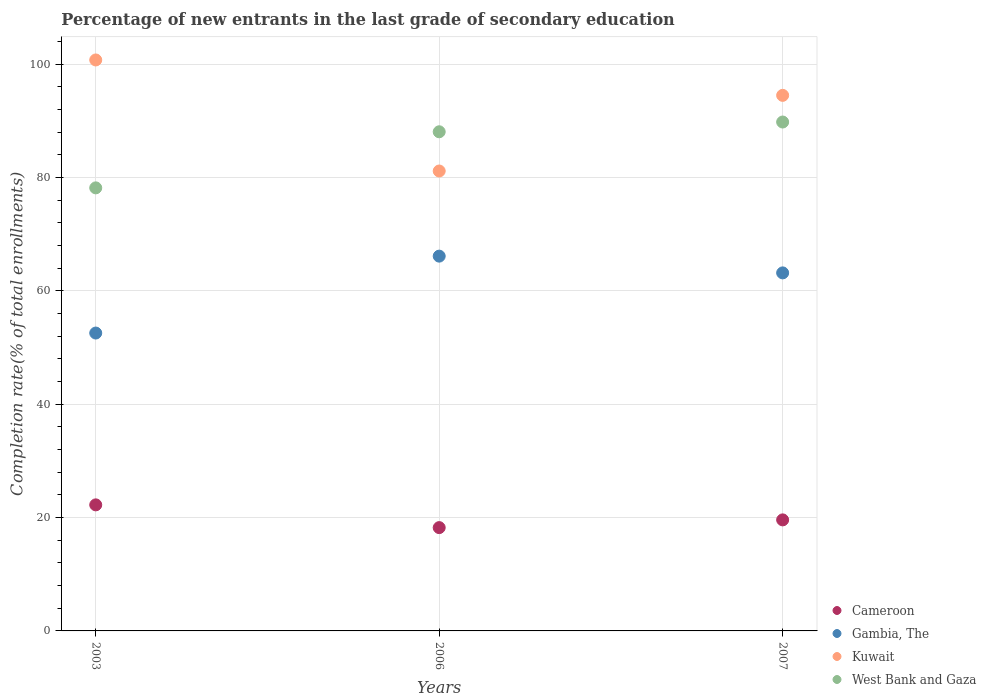Is the number of dotlines equal to the number of legend labels?
Ensure brevity in your answer.  Yes. What is the percentage of new entrants in Kuwait in 2003?
Your answer should be very brief. 100.72. Across all years, what is the maximum percentage of new entrants in Cameroon?
Provide a succinct answer. 22.24. Across all years, what is the minimum percentage of new entrants in Kuwait?
Provide a short and direct response. 81.13. In which year was the percentage of new entrants in Cameroon minimum?
Offer a terse response. 2006. What is the total percentage of new entrants in Cameroon in the graph?
Provide a short and direct response. 60.05. What is the difference between the percentage of new entrants in West Bank and Gaza in 2003 and that in 2006?
Make the answer very short. -9.89. What is the difference between the percentage of new entrants in West Bank and Gaza in 2006 and the percentage of new entrants in Cameroon in 2007?
Make the answer very short. 68.46. What is the average percentage of new entrants in Cameroon per year?
Provide a succinct answer. 20.02. In the year 2006, what is the difference between the percentage of new entrants in Kuwait and percentage of new entrants in Cameroon?
Your answer should be very brief. 62.91. What is the ratio of the percentage of new entrants in Kuwait in 2006 to that in 2007?
Your answer should be very brief. 0.86. Is the difference between the percentage of new entrants in Kuwait in 2003 and 2006 greater than the difference between the percentage of new entrants in Cameroon in 2003 and 2006?
Make the answer very short. Yes. What is the difference between the highest and the second highest percentage of new entrants in Kuwait?
Your answer should be very brief. 6.25. What is the difference between the highest and the lowest percentage of new entrants in Cameroon?
Provide a succinct answer. 4.01. Is the sum of the percentage of new entrants in Gambia, The in 2003 and 2006 greater than the maximum percentage of new entrants in Kuwait across all years?
Give a very brief answer. Yes. Is the percentage of new entrants in West Bank and Gaza strictly greater than the percentage of new entrants in Kuwait over the years?
Give a very brief answer. No. Is the percentage of new entrants in Kuwait strictly less than the percentage of new entrants in Gambia, The over the years?
Your answer should be compact. No. How many dotlines are there?
Make the answer very short. 4. How many years are there in the graph?
Give a very brief answer. 3. Are the values on the major ticks of Y-axis written in scientific E-notation?
Your answer should be very brief. No. Does the graph contain any zero values?
Make the answer very short. No. Does the graph contain grids?
Your answer should be compact. Yes. How many legend labels are there?
Provide a succinct answer. 4. How are the legend labels stacked?
Your response must be concise. Vertical. What is the title of the graph?
Your response must be concise. Percentage of new entrants in the last grade of secondary education. What is the label or title of the Y-axis?
Give a very brief answer. Completion rate(% of total enrollments). What is the Completion rate(% of total enrollments) in Cameroon in 2003?
Keep it short and to the point. 22.24. What is the Completion rate(% of total enrollments) in Gambia, The in 2003?
Ensure brevity in your answer.  52.55. What is the Completion rate(% of total enrollments) of Kuwait in 2003?
Make the answer very short. 100.72. What is the Completion rate(% of total enrollments) of West Bank and Gaza in 2003?
Make the answer very short. 78.15. What is the Completion rate(% of total enrollments) of Cameroon in 2006?
Your response must be concise. 18.22. What is the Completion rate(% of total enrollments) of Gambia, The in 2006?
Ensure brevity in your answer.  66.11. What is the Completion rate(% of total enrollments) of Kuwait in 2006?
Offer a terse response. 81.13. What is the Completion rate(% of total enrollments) of West Bank and Gaza in 2006?
Ensure brevity in your answer.  88.05. What is the Completion rate(% of total enrollments) of Cameroon in 2007?
Provide a succinct answer. 19.59. What is the Completion rate(% of total enrollments) in Gambia, The in 2007?
Keep it short and to the point. 63.16. What is the Completion rate(% of total enrollments) of Kuwait in 2007?
Provide a short and direct response. 94.47. What is the Completion rate(% of total enrollments) in West Bank and Gaza in 2007?
Your answer should be very brief. 89.77. Across all years, what is the maximum Completion rate(% of total enrollments) in Cameroon?
Your answer should be compact. 22.24. Across all years, what is the maximum Completion rate(% of total enrollments) in Gambia, The?
Provide a short and direct response. 66.11. Across all years, what is the maximum Completion rate(% of total enrollments) in Kuwait?
Offer a terse response. 100.72. Across all years, what is the maximum Completion rate(% of total enrollments) of West Bank and Gaza?
Your response must be concise. 89.77. Across all years, what is the minimum Completion rate(% of total enrollments) of Cameroon?
Keep it short and to the point. 18.22. Across all years, what is the minimum Completion rate(% of total enrollments) of Gambia, The?
Make the answer very short. 52.55. Across all years, what is the minimum Completion rate(% of total enrollments) in Kuwait?
Give a very brief answer. 81.13. Across all years, what is the minimum Completion rate(% of total enrollments) of West Bank and Gaza?
Ensure brevity in your answer.  78.15. What is the total Completion rate(% of total enrollments) in Cameroon in the graph?
Make the answer very short. 60.05. What is the total Completion rate(% of total enrollments) in Gambia, The in the graph?
Offer a very short reply. 181.82. What is the total Completion rate(% of total enrollments) in Kuwait in the graph?
Provide a short and direct response. 276.32. What is the total Completion rate(% of total enrollments) of West Bank and Gaza in the graph?
Your answer should be compact. 255.97. What is the difference between the Completion rate(% of total enrollments) in Cameroon in 2003 and that in 2006?
Your answer should be compact. 4.01. What is the difference between the Completion rate(% of total enrollments) of Gambia, The in 2003 and that in 2006?
Your answer should be very brief. -13.57. What is the difference between the Completion rate(% of total enrollments) of Kuwait in 2003 and that in 2006?
Your response must be concise. 19.59. What is the difference between the Completion rate(% of total enrollments) in West Bank and Gaza in 2003 and that in 2006?
Offer a very short reply. -9.89. What is the difference between the Completion rate(% of total enrollments) in Cameroon in 2003 and that in 2007?
Offer a very short reply. 2.65. What is the difference between the Completion rate(% of total enrollments) in Gambia, The in 2003 and that in 2007?
Your answer should be compact. -10.61. What is the difference between the Completion rate(% of total enrollments) in Kuwait in 2003 and that in 2007?
Offer a very short reply. 6.25. What is the difference between the Completion rate(% of total enrollments) in West Bank and Gaza in 2003 and that in 2007?
Your answer should be very brief. -11.62. What is the difference between the Completion rate(% of total enrollments) in Cameroon in 2006 and that in 2007?
Give a very brief answer. -1.36. What is the difference between the Completion rate(% of total enrollments) in Gambia, The in 2006 and that in 2007?
Your response must be concise. 2.96. What is the difference between the Completion rate(% of total enrollments) of Kuwait in 2006 and that in 2007?
Your response must be concise. -13.34. What is the difference between the Completion rate(% of total enrollments) of West Bank and Gaza in 2006 and that in 2007?
Ensure brevity in your answer.  -1.72. What is the difference between the Completion rate(% of total enrollments) in Cameroon in 2003 and the Completion rate(% of total enrollments) in Gambia, The in 2006?
Provide a short and direct response. -43.88. What is the difference between the Completion rate(% of total enrollments) in Cameroon in 2003 and the Completion rate(% of total enrollments) in Kuwait in 2006?
Offer a very short reply. -58.89. What is the difference between the Completion rate(% of total enrollments) in Cameroon in 2003 and the Completion rate(% of total enrollments) in West Bank and Gaza in 2006?
Keep it short and to the point. -65.81. What is the difference between the Completion rate(% of total enrollments) of Gambia, The in 2003 and the Completion rate(% of total enrollments) of Kuwait in 2006?
Your answer should be very brief. -28.58. What is the difference between the Completion rate(% of total enrollments) in Gambia, The in 2003 and the Completion rate(% of total enrollments) in West Bank and Gaza in 2006?
Give a very brief answer. -35.5. What is the difference between the Completion rate(% of total enrollments) in Kuwait in 2003 and the Completion rate(% of total enrollments) in West Bank and Gaza in 2006?
Offer a terse response. 12.67. What is the difference between the Completion rate(% of total enrollments) of Cameroon in 2003 and the Completion rate(% of total enrollments) of Gambia, The in 2007?
Your answer should be compact. -40.92. What is the difference between the Completion rate(% of total enrollments) in Cameroon in 2003 and the Completion rate(% of total enrollments) in Kuwait in 2007?
Your response must be concise. -72.24. What is the difference between the Completion rate(% of total enrollments) of Cameroon in 2003 and the Completion rate(% of total enrollments) of West Bank and Gaza in 2007?
Offer a very short reply. -67.53. What is the difference between the Completion rate(% of total enrollments) in Gambia, The in 2003 and the Completion rate(% of total enrollments) in Kuwait in 2007?
Ensure brevity in your answer.  -41.93. What is the difference between the Completion rate(% of total enrollments) in Gambia, The in 2003 and the Completion rate(% of total enrollments) in West Bank and Gaza in 2007?
Make the answer very short. -37.22. What is the difference between the Completion rate(% of total enrollments) in Kuwait in 2003 and the Completion rate(% of total enrollments) in West Bank and Gaza in 2007?
Provide a succinct answer. 10.95. What is the difference between the Completion rate(% of total enrollments) in Cameroon in 2006 and the Completion rate(% of total enrollments) in Gambia, The in 2007?
Your answer should be very brief. -44.93. What is the difference between the Completion rate(% of total enrollments) of Cameroon in 2006 and the Completion rate(% of total enrollments) of Kuwait in 2007?
Ensure brevity in your answer.  -76.25. What is the difference between the Completion rate(% of total enrollments) of Cameroon in 2006 and the Completion rate(% of total enrollments) of West Bank and Gaza in 2007?
Your answer should be compact. -71.55. What is the difference between the Completion rate(% of total enrollments) of Gambia, The in 2006 and the Completion rate(% of total enrollments) of Kuwait in 2007?
Provide a short and direct response. -28.36. What is the difference between the Completion rate(% of total enrollments) in Gambia, The in 2006 and the Completion rate(% of total enrollments) in West Bank and Gaza in 2007?
Your answer should be very brief. -23.66. What is the difference between the Completion rate(% of total enrollments) in Kuwait in 2006 and the Completion rate(% of total enrollments) in West Bank and Gaza in 2007?
Your response must be concise. -8.64. What is the average Completion rate(% of total enrollments) in Cameroon per year?
Provide a short and direct response. 20.02. What is the average Completion rate(% of total enrollments) of Gambia, The per year?
Your answer should be very brief. 60.61. What is the average Completion rate(% of total enrollments) in Kuwait per year?
Ensure brevity in your answer.  92.11. What is the average Completion rate(% of total enrollments) of West Bank and Gaza per year?
Provide a short and direct response. 85.32. In the year 2003, what is the difference between the Completion rate(% of total enrollments) in Cameroon and Completion rate(% of total enrollments) in Gambia, The?
Provide a short and direct response. -30.31. In the year 2003, what is the difference between the Completion rate(% of total enrollments) in Cameroon and Completion rate(% of total enrollments) in Kuwait?
Provide a succinct answer. -78.48. In the year 2003, what is the difference between the Completion rate(% of total enrollments) of Cameroon and Completion rate(% of total enrollments) of West Bank and Gaza?
Offer a very short reply. -55.92. In the year 2003, what is the difference between the Completion rate(% of total enrollments) of Gambia, The and Completion rate(% of total enrollments) of Kuwait?
Your response must be concise. -48.17. In the year 2003, what is the difference between the Completion rate(% of total enrollments) in Gambia, The and Completion rate(% of total enrollments) in West Bank and Gaza?
Provide a short and direct response. -25.61. In the year 2003, what is the difference between the Completion rate(% of total enrollments) in Kuwait and Completion rate(% of total enrollments) in West Bank and Gaza?
Keep it short and to the point. 22.56. In the year 2006, what is the difference between the Completion rate(% of total enrollments) in Cameroon and Completion rate(% of total enrollments) in Gambia, The?
Provide a succinct answer. -47.89. In the year 2006, what is the difference between the Completion rate(% of total enrollments) in Cameroon and Completion rate(% of total enrollments) in Kuwait?
Your answer should be compact. -62.91. In the year 2006, what is the difference between the Completion rate(% of total enrollments) in Cameroon and Completion rate(% of total enrollments) in West Bank and Gaza?
Your answer should be very brief. -69.83. In the year 2006, what is the difference between the Completion rate(% of total enrollments) of Gambia, The and Completion rate(% of total enrollments) of Kuwait?
Provide a short and direct response. -15.02. In the year 2006, what is the difference between the Completion rate(% of total enrollments) in Gambia, The and Completion rate(% of total enrollments) in West Bank and Gaza?
Make the answer very short. -21.94. In the year 2006, what is the difference between the Completion rate(% of total enrollments) of Kuwait and Completion rate(% of total enrollments) of West Bank and Gaza?
Keep it short and to the point. -6.92. In the year 2007, what is the difference between the Completion rate(% of total enrollments) in Cameroon and Completion rate(% of total enrollments) in Gambia, The?
Provide a short and direct response. -43.57. In the year 2007, what is the difference between the Completion rate(% of total enrollments) in Cameroon and Completion rate(% of total enrollments) in Kuwait?
Keep it short and to the point. -74.89. In the year 2007, what is the difference between the Completion rate(% of total enrollments) of Cameroon and Completion rate(% of total enrollments) of West Bank and Gaza?
Your response must be concise. -70.18. In the year 2007, what is the difference between the Completion rate(% of total enrollments) of Gambia, The and Completion rate(% of total enrollments) of Kuwait?
Give a very brief answer. -31.32. In the year 2007, what is the difference between the Completion rate(% of total enrollments) in Gambia, The and Completion rate(% of total enrollments) in West Bank and Gaza?
Provide a short and direct response. -26.61. In the year 2007, what is the difference between the Completion rate(% of total enrollments) in Kuwait and Completion rate(% of total enrollments) in West Bank and Gaza?
Provide a succinct answer. 4.7. What is the ratio of the Completion rate(% of total enrollments) of Cameroon in 2003 to that in 2006?
Offer a very short reply. 1.22. What is the ratio of the Completion rate(% of total enrollments) of Gambia, The in 2003 to that in 2006?
Your answer should be compact. 0.79. What is the ratio of the Completion rate(% of total enrollments) in Kuwait in 2003 to that in 2006?
Give a very brief answer. 1.24. What is the ratio of the Completion rate(% of total enrollments) of West Bank and Gaza in 2003 to that in 2006?
Make the answer very short. 0.89. What is the ratio of the Completion rate(% of total enrollments) of Cameroon in 2003 to that in 2007?
Your answer should be compact. 1.14. What is the ratio of the Completion rate(% of total enrollments) of Gambia, The in 2003 to that in 2007?
Provide a succinct answer. 0.83. What is the ratio of the Completion rate(% of total enrollments) in Kuwait in 2003 to that in 2007?
Ensure brevity in your answer.  1.07. What is the ratio of the Completion rate(% of total enrollments) of West Bank and Gaza in 2003 to that in 2007?
Give a very brief answer. 0.87. What is the ratio of the Completion rate(% of total enrollments) of Cameroon in 2006 to that in 2007?
Provide a succinct answer. 0.93. What is the ratio of the Completion rate(% of total enrollments) in Gambia, The in 2006 to that in 2007?
Your response must be concise. 1.05. What is the ratio of the Completion rate(% of total enrollments) of Kuwait in 2006 to that in 2007?
Your answer should be very brief. 0.86. What is the ratio of the Completion rate(% of total enrollments) in West Bank and Gaza in 2006 to that in 2007?
Ensure brevity in your answer.  0.98. What is the difference between the highest and the second highest Completion rate(% of total enrollments) of Cameroon?
Ensure brevity in your answer.  2.65. What is the difference between the highest and the second highest Completion rate(% of total enrollments) of Gambia, The?
Keep it short and to the point. 2.96. What is the difference between the highest and the second highest Completion rate(% of total enrollments) in Kuwait?
Make the answer very short. 6.25. What is the difference between the highest and the second highest Completion rate(% of total enrollments) in West Bank and Gaza?
Your answer should be compact. 1.72. What is the difference between the highest and the lowest Completion rate(% of total enrollments) of Cameroon?
Keep it short and to the point. 4.01. What is the difference between the highest and the lowest Completion rate(% of total enrollments) in Gambia, The?
Your answer should be compact. 13.57. What is the difference between the highest and the lowest Completion rate(% of total enrollments) in Kuwait?
Your answer should be compact. 19.59. What is the difference between the highest and the lowest Completion rate(% of total enrollments) in West Bank and Gaza?
Make the answer very short. 11.62. 